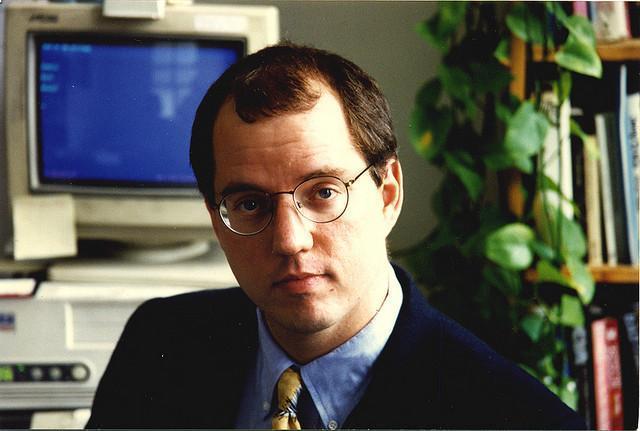How many bookshelves are visible?
Give a very brief answer. 1. How many books are there?
Give a very brief answer. 2. How many women on bikes are in the picture?
Give a very brief answer. 0. 